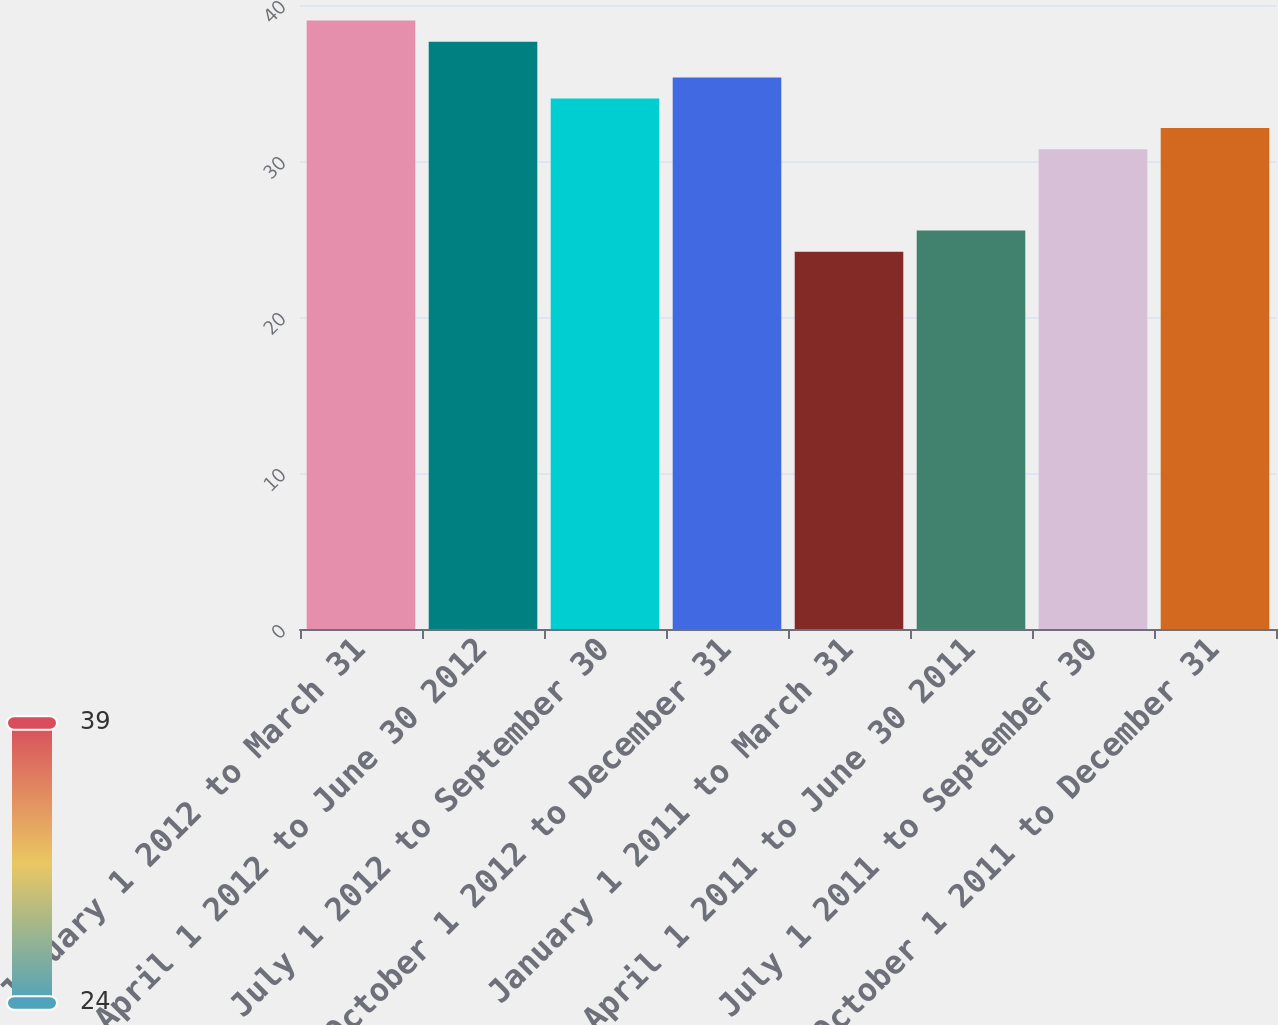Convert chart. <chart><loc_0><loc_0><loc_500><loc_500><bar_chart><fcel>January 1 2012 to March 31<fcel>April 1 2012 to June 30 2012<fcel>July 1 2012 to September 30<fcel>October 1 2012 to December 31<fcel>January 1 2011 to March 31<fcel>April 1 2011 to June 30 2011<fcel>July 1 2011 to September 30<fcel>October 1 2011 to December 31<nl><fcel>39.01<fcel>37.65<fcel>34<fcel>35.36<fcel>24.19<fcel>25.55<fcel>30.75<fcel>32.11<nl></chart> 